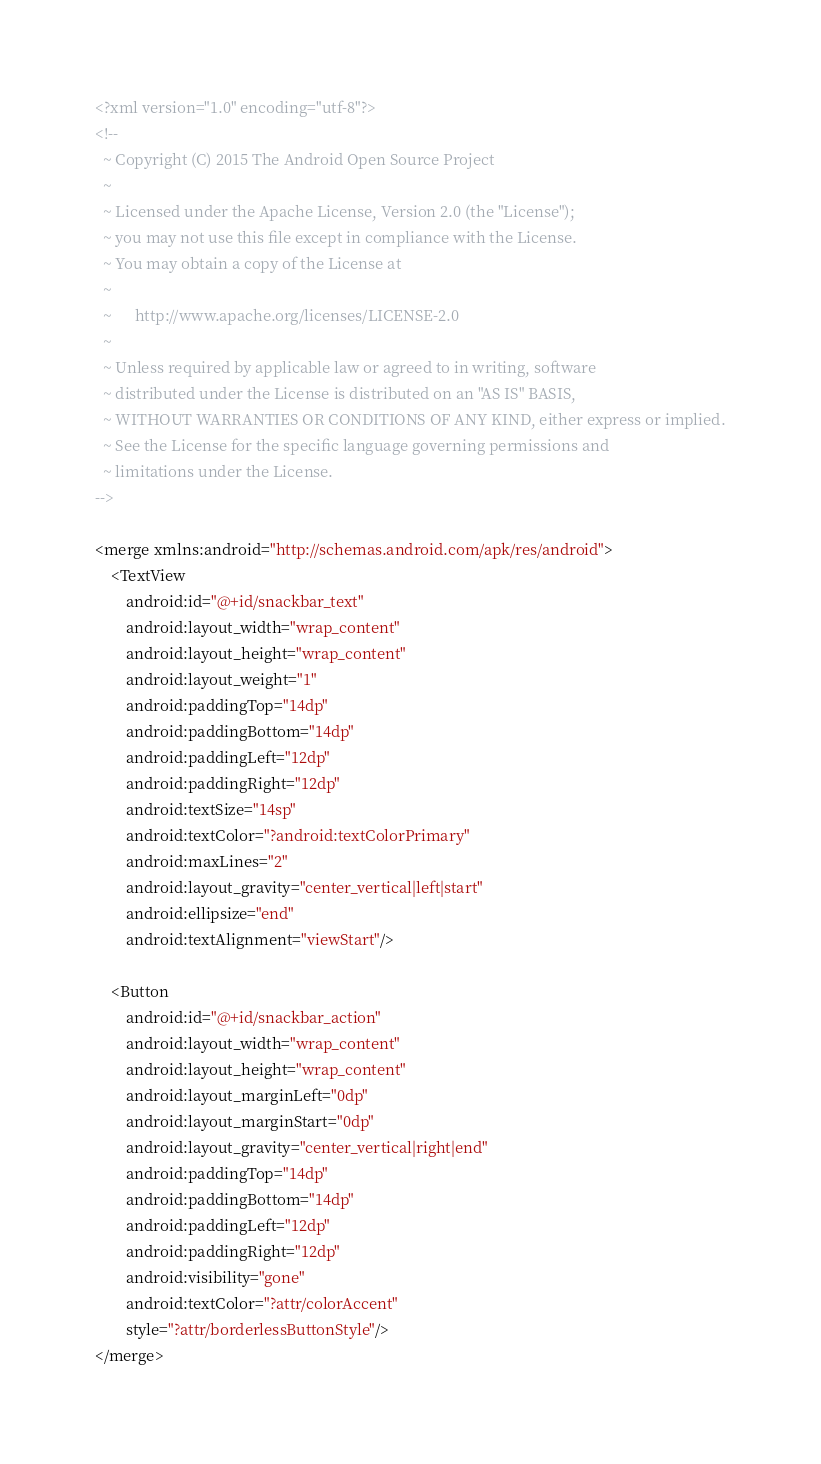<code> <loc_0><loc_0><loc_500><loc_500><_XML_><?xml version="1.0" encoding="utf-8"?>
<!--
  ~ Copyright (C) 2015 The Android Open Source Project
  ~
  ~ Licensed under the Apache License, Version 2.0 (the "License");
  ~ you may not use this file except in compliance with the License.
  ~ You may obtain a copy of the License at
  ~
  ~      http://www.apache.org/licenses/LICENSE-2.0
  ~
  ~ Unless required by applicable law or agreed to in writing, software
  ~ distributed under the License is distributed on an "AS IS" BASIS,
  ~ WITHOUT WARRANTIES OR CONDITIONS OF ANY KIND, either express or implied.
  ~ See the License for the specific language governing permissions and
  ~ limitations under the License.
-->

<merge xmlns:android="http://schemas.android.com/apk/res/android">
    <TextView
        android:id="@+id/snackbar_text"
        android:layout_width="wrap_content"
        android:layout_height="wrap_content"
        android:layout_weight="1"
        android:paddingTop="14dp"
        android:paddingBottom="14dp"
        android:paddingLeft="12dp"
        android:paddingRight="12dp"
        android:textSize="14sp"
        android:textColor="?android:textColorPrimary"
        android:maxLines="2"
        android:layout_gravity="center_vertical|left|start"
        android:ellipsize="end"
        android:textAlignment="viewStart"/>

    <Button
        android:id="@+id/snackbar_action"
        android:layout_width="wrap_content"
        android:layout_height="wrap_content"
        android:layout_marginLeft="0dp"
        android:layout_marginStart="0dp"
        android:layout_gravity="center_vertical|right|end"
        android:paddingTop="14dp"
        android:paddingBottom="14dp"
        android:paddingLeft="12dp"
        android:paddingRight="12dp"
        android:visibility="gone"
        android:textColor="?attr/colorAccent"
        style="?attr/borderlessButtonStyle"/>
</merge></code> 